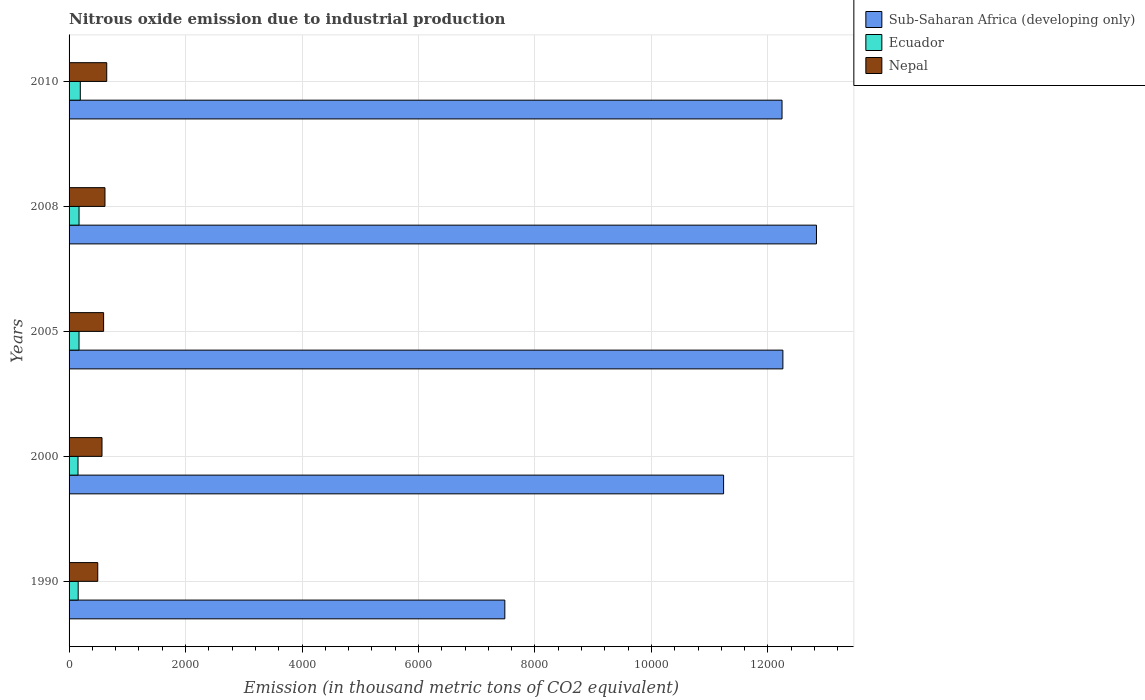How many different coloured bars are there?
Your response must be concise. 3. How many groups of bars are there?
Provide a short and direct response. 5. Are the number of bars on each tick of the Y-axis equal?
Give a very brief answer. Yes. How many bars are there on the 4th tick from the bottom?
Make the answer very short. 3. What is the label of the 2nd group of bars from the top?
Give a very brief answer. 2008. In how many cases, is the number of bars for a given year not equal to the number of legend labels?
Your response must be concise. 0. What is the amount of nitrous oxide emitted in Ecuador in 2008?
Your response must be concise. 171.4. Across all years, what is the maximum amount of nitrous oxide emitted in Nepal?
Your response must be concise. 646.7. Across all years, what is the minimum amount of nitrous oxide emitted in Nepal?
Your response must be concise. 492.4. In which year was the amount of nitrous oxide emitted in Sub-Saharan Africa (developing only) maximum?
Keep it short and to the point. 2008. In which year was the amount of nitrous oxide emitted in Ecuador minimum?
Give a very brief answer. 2000. What is the total amount of nitrous oxide emitted in Nepal in the graph?
Provide a short and direct response. 2913.8. What is the difference between the amount of nitrous oxide emitted in Sub-Saharan Africa (developing only) in 2005 and that in 2010?
Your response must be concise. 14.6. What is the difference between the amount of nitrous oxide emitted in Nepal in 2010 and the amount of nitrous oxide emitted in Ecuador in 2000?
Keep it short and to the point. 493. What is the average amount of nitrous oxide emitted in Ecuador per year?
Your answer should be compact. 169.1. In the year 1990, what is the difference between the amount of nitrous oxide emitted in Ecuador and amount of nitrous oxide emitted in Sub-Saharan Africa (developing only)?
Your answer should be compact. -7325.8. What is the ratio of the amount of nitrous oxide emitted in Ecuador in 2000 to that in 2010?
Provide a succinct answer. 0.8. Is the difference between the amount of nitrous oxide emitted in Ecuador in 2005 and 2008 greater than the difference between the amount of nitrous oxide emitted in Sub-Saharan Africa (developing only) in 2005 and 2008?
Provide a short and direct response. Yes. What is the difference between the highest and the second highest amount of nitrous oxide emitted in Sub-Saharan Africa (developing only)?
Your answer should be compact. 576.6. What is the difference between the highest and the lowest amount of nitrous oxide emitted in Sub-Saharan Africa (developing only)?
Keep it short and to the point. 5351.1. In how many years, is the amount of nitrous oxide emitted in Nepal greater than the average amount of nitrous oxide emitted in Nepal taken over all years?
Keep it short and to the point. 3. Is the sum of the amount of nitrous oxide emitted in Nepal in 1990 and 2008 greater than the maximum amount of nitrous oxide emitted in Sub-Saharan Africa (developing only) across all years?
Offer a terse response. No. What does the 3rd bar from the top in 2000 represents?
Make the answer very short. Sub-Saharan Africa (developing only). What does the 2nd bar from the bottom in 2008 represents?
Your answer should be very brief. Ecuador. Is it the case that in every year, the sum of the amount of nitrous oxide emitted in Nepal and amount of nitrous oxide emitted in Ecuador is greater than the amount of nitrous oxide emitted in Sub-Saharan Africa (developing only)?
Ensure brevity in your answer.  No. How many bars are there?
Make the answer very short. 15. Does the graph contain grids?
Ensure brevity in your answer.  Yes. Where does the legend appear in the graph?
Offer a terse response. Top right. How many legend labels are there?
Provide a short and direct response. 3. What is the title of the graph?
Give a very brief answer. Nitrous oxide emission due to industrial production. What is the label or title of the X-axis?
Offer a very short reply. Emission (in thousand metric tons of CO2 equivalent). What is the Emission (in thousand metric tons of CO2 equivalent) in Sub-Saharan Africa (developing only) in 1990?
Your response must be concise. 7482.3. What is the Emission (in thousand metric tons of CO2 equivalent) of Ecuador in 1990?
Keep it short and to the point. 156.5. What is the Emission (in thousand metric tons of CO2 equivalent) of Nepal in 1990?
Your response must be concise. 492.4. What is the Emission (in thousand metric tons of CO2 equivalent) in Sub-Saharan Africa (developing only) in 2000?
Keep it short and to the point. 1.12e+04. What is the Emission (in thousand metric tons of CO2 equivalent) of Ecuador in 2000?
Your answer should be compact. 153.7. What is the Emission (in thousand metric tons of CO2 equivalent) of Nepal in 2000?
Offer a terse response. 565.3. What is the Emission (in thousand metric tons of CO2 equivalent) in Sub-Saharan Africa (developing only) in 2005?
Keep it short and to the point. 1.23e+04. What is the Emission (in thousand metric tons of CO2 equivalent) in Ecuador in 2005?
Ensure brevity in your answer.  171.1. What is the Emission (in thousand metric tons of CO2 equivalent) of Nepal in 2005?
Your answer should be very brief. 593.1. What is the Emission (in thousand metric tons of CO2 equivalent) of Sub-Saharan Africa (developing only) in 2008?
Provide a short and direct response. 1.28e+04. What is the Emission (in thousand metric tons of CO2 equivalent) of Ecuador in 2008?
Your response must be concise. 171.4. What is the Emission (in thousand metric tons of CO2 equivalent) of Nepal in 2008?
Your answer should be very brief. 616.3. What is the Emission (in thousand metric tons of CO2 equivalent) of Sub-Saharan Africa (developing only) in 2010?
Your response must be concise. 1.22e+04. What is the Emission (in thousand metric tons of CO2 equivalent) in Ecuador in 2010?
Keep it short and to the point. 192.8. What is the Emission (in thousand metric tons of CO2 equivalent) of Nepal in 2010?
Your response must be concise. 646.7. Across all years, what is the maximum Emission (in thousand metric tons of CO2 equivalent) of Sub-Saharan Africa (developing only)?
Give a very brief answer. 1.28e+04. Across all years, what is the maximum Emission (in thousand metric tons of CO2 equivalent) of Ecuador?
Offer a very short reply. 192.8. Across all years, what is the maximum Emission (in thousand metric tons of CO2 equivalent) in Nepal?
Your answer should be compact. 646.7. Across all years, what is the minimum Emission (in thousand metric tons of CO2 equivalent) in Sub-Saharan Africa (developing only)?
Give a very brief answer. 7482.3. Across all years, what is the minimum Emission (in thousand metric tons of CO2 equivalent) of Ecuador?
Your answer should be compact. 153.7. Across all years, what is the minimum Emission (in thousand metric tons of CO2 equivalent) of Nepal?
Ensure brevity in your answer.  492.4. What is the total Emission (in thousand metric tons of CO2 equivalent) of Sub-Saharan Africa (developing only) in the graph?
Make the answer very short. 5.61e+04. What is the total Emission (in thousand metric tons of CO2 equivalent) of Ecuador in the graph?
Provide a succinct answer. 845.5. What is the total Emission (in thousand metric tons of CO2 equivalent) in Nepal in the graph?
Keep it short and to the point. 2913.8. What is the difference between the Emission (in thousand metric tons of CO2 equivalent) of Sub-Saharan Africa (developing only) in 1990 and that in 2000?
Provide a short and direct response. -3756.4. What is the difference between the Emission (in thousand metric tons of CO2 equivalent) in Nepal in 1990 and that in 2000?
Your answer should be compact. -72.9. What is the difference between the Emission (in thousand metric tons of CO2 equivalent) in Sub-Saharan Africa (developing only) in 1990 and that in 2005?
Your answer should be very brief. -4774.5. What is the difference between the Emission (in thousand metric tons of CO2 equivalent) in Ecuador in 1990 and that in 2005?
Keep it short and to the point. -14.6. What is the difference between the Emission (in thousand metric tons of CO2 equivalent) in Nepal in 1990 and that in 2005?
Provide a succinct answer. -100.7. What is the difference between the Emission (in thousand metric tons of CO2 equivalent) of Sub-Saharan Africa (developing only) in 1990 and that in 2008?
Offer a terse response. -5351.1. What is the difference between the Emission (in thousand metric tons of CO2 equivalent) in Ecuador in 1990 and that in 2008?
Offer a terse response. -14.9. What is the difference between the Emission (in thousand metric tons of CO2 equivalent) of Nepal in 1990 and that in 2008?
Your response must be concise. -123.9. What is the difference between the Emission (in thousand metric tons of CO2 equivalent) of Sub-Saharan Africa (developing only) in 1990 and that in 2010?
Provide a succinct answer. -4759.9. What is the difference between the Emission (in thousand metric tons of CO2 equivalent) in Ecuador in 1990 and that in 2010?
Your answer should be compact. -36.3. What is the difference between the Emission (in thousand metric tons of CO2 equivalent) of Nepal in 1990 and that in 2010?
Keep it short and to the point. -154.3. What is the difference between the Emission (in thousand metric tons of CO2 equivalent) of Sub-Saharan Africa (developing only) in 2000 and that in 2005?
Your response must be concise. -1018.1. What is the difference between the Emission (in thousand metric tons of CO2 equivalent) of Ecuador in 2000 and that in 2005?
Provide a succinct answer. -17.4. What is the difference between the Emission (in thousand metric tons of CO2 equivalent) of Nepal in 2000 and that in 2005?
Give a very brief answer. -27.8. What is the difference between the Emission (in thousand metric tons of CO2 equivalent) of Sub-Saharan Africa (developing only) in 2000 and that in 2008?
Provide a short and direct response. -1594.7. What is the difference between the Emission (in thousand metric tons of CO2 equivalent) in Ecuador in 2000 and that in 2008?
Make the answer very short. -17.7. What is the difference between the Emission (in thousand metric tons of CO2 equivalent) of Nepal in 2000 and that in 2008?
Your answer should be compact. -51. What is the difference between the Emission (in thousand metric tons of CO2 equivalent) in Sub-Saharan Africa (developing only) in 2000 and that in 2010?
Provide a succinct answer. -1003.5. What is the difference between the Emission (in thousand metric tons of CO2 equivalent) in Ecuador in 2000 and that in 2010?
Your answer should be compact. -39.1. What is the difference between the Emission (in thousand metric tons of CO2 equivalent) in Nepal in 2000 and that in 2010?
Offer a terse response. -81.4. What is the difference between the Emission (in thousand metric tons of CO2 equivalent) in Sub-Saharan Africa (developing only) in 2005 and that in 2008?
Offer a terse response. -576.6. What is the difference between the Emission (in thousand metric tons of CO2 equivalent) of Ecuador in 2005 and that in 2008?
Offer a terse response. -0.3. What is the difference between the Emission (in thousand metric tons of CO2 equivalent) of Nepal in 2005 and that in 2008?
Your response must be concise. -23.2. What is the difference between the Emission (in thousand metric tons of CO2 equivalent) in Ecuador in 2005 and that in 2010?
Provide a short and direct response. -21.7. What is the difference between the Emission (in thousand metric tons of CO2 equivalent) in Nepal in 2005 and that in 2010?
Provide a short and direct response. -53.6. What is the difference between the Emission (in thousand metric tons of CO2 equivalent) of Sub-Saharan Africa (developing only) in 2008 and that in 2010?
Make the answer very short. 591.2. What is the difference between the Emission (in thousand metric tons of CO2 equivalent) in Ecuador in 2008 and that in 2010?
Your answer should be very brief. -21.4. What is the difference between the Emission (in thousand metric tons of CO2 equivalent) in Nepal in 2008 and that in 2010?
Your answer should be compact. -30.4. What is the difference between the Emission (in thousand metric tons of CO2 equivalent) of Sub-Saharan Africa (developing only) in 1990 and the Emission (in thousand metric tons of CO2 equivalent) of Ecuador in 2000?
Offer a terse response. 7328.6. What is the difference between the Emission (in thousand metric tons of CO2 equivalent) of Sub-Saharan Africa (developing only) in 1990 and the Emission (in thousand metric tons of CO2 equivalent) of Nepal in 2000?
Your answer should be compact. 6917. What is the difference between the Emission (in thousand metric tons of CO2 equivalent) of Ecuador in 1990 and the Emission (in thousand metric tons of CO2 equivalent) of Nepal in 2000?
Make the answer very short. -408.8. What is the difference between the Emission (in thousand metric tons of CO2 equivalent) in Sub-Saharan Africa (developing only) in 1990 and the Emission (in thousand metric tons of CO2 equivalent) in Ecuador in 2005?
Your answer should be very brief. 7311.2. What is the difference between the Emission (in thousand metric tons of CO2 equivalent) of Sub-Saharan Africa (developing only) in 1990 and the Emission (in thousand metric tons of CO2 equivalent) of Nepal in 2005?
Provide a succinct answer. 6889.2. What is the difference between the Emission (in thousand metric tons of CO2 equivalent) of Ecuador in 1990 and the Emission (in thousand metric tons of CO2 equivalent) of Nepal in 2005?
Offer a very short reply. -436.6. What is the difference between the Emission (in thousand metric tons of CO2 equivalent) of Sub-Saharan Africa (developing only) in 1990 and the Emission (in thousand metric tons of CO2 equivalent) of Ecuador in 2008?
Offer a terse response. 7310.9. What is the difference between the Emission (in thousand metric tons of CO2 equivalent) in Sub-Saharan Africa (developing only) in 1990 and the Emission (in thousand metric tons of CO2 equivalent) in Nepal in 2008?
Offer a terse response. 6866. What is the difference between the Emission (in thousand metric tons of CO2 equivalent) of Ecuador in 1990 and the Emission (in thousand metric tons of CO2 equivalent) of Nepal in 2008?
Offer a very short reply. -459.8. What is the difference between the Emission (in thousand metric tons of CO2 equivalent) of Sub-Saharan Africa (developing only) in 1990 and the Emission (in thousand metric tons of CO2 equivalent) of Ecuador in 2010?
Provide a short and direct response. 7289.5. What is the difference between the Emission (in thousand metric tons of CO2 equivalent) in Sub-Saharan Africa (developing only) in 1990 and the Emission (in thousand metric tons of CO2 equivalent) in Nepal in 2010?
Ensure brevity in your answer.  6835.6. What is the difference between the Emission (in thousand metric tons of CO2 equivalent) in Ecuador in 1990 and the Emission (in thousand metric tons of CO2 equivalent) in Nepal in 2010?
Offer a very short reply. -490.2. What is the difference between the Emission (in thousand metric tons of CO2 equivalent) of Sub-Saharan Africa (developing only) in 2000 and the Emission (in thousand metric tons of CO2 equivalent) of Ecuador in 2005?
Make the answer very short. 1.11e+04. What is the difference between the Emission (in thousand metric tons of CO2 equivalent) of Sub-Saharan Africa (developing only) in 2000 and the Emission (in thousand metric tons of CO2 equivalent) of Nepal in 2005?
Your response must be concise. 1.06e+04. What is the difference between the Emission (in thousand metric tons of CO2 equivalent) of Ecuador in 2000 and the Emission (in thousand metric tons of CO2 equivalent) of Nepal in 2005?
Make the answer very short. -439.4. What is the difference between the Emission (in thousand metric tons of CO2 equivalent) in Sub-Saharan Africa (developing only) in 2000 and the Emission (in thousand metric tons of CO2 equivalent) in Ecuador in 2008?
Offer a very short reply. 1.11e+04. What is the difference between the Emission (in thousand metric tons of CO2 equivalent) of Sub-Saharan Africa (developing only) in 2000 and the Emission (in thousand metric tons of CO2 equivalent) of Nepal in 2008?
Offer a very short reply. 1.06e+04. What is the difference between the Emission (in thousand metric tons of CO2 equivalent) in Ecuador in 2000 and the Emission (in thousand metric tons of CO2 equivalent) in Nepal in 2008?
Give a very brief answer. -462.6. What is the difference between the Emission (in thousand metric tons of CO2 equivalent) in Sub-Saharan Africa (developing only) in 2000 and the Emission (in thousand metric tons of CO2 equivalent) in Ecuador in 2010?
Your answer should be very brief. 1.10e+04. What is the difference between the Emission (in thousand metric tons of CO2 equivalent) of Sub-Saharan Africa (developing only) in 2000 and the Emission (in thousand metric tons of CO2 equivalent) of Nepal in 2010?
Make the answer very short. 1.06e+04. What is the difference between the Emission (in thousand metric tons of CO2 equivalent) in Ecuador in 2000 and the Emission (in thousand metric tons of CO2 equivalent) in Nepal in 2010?
Give a very brief answer. -493. What is the difference between the Emission (in thousand metric tons of CO2 equivalent) of Sub-Saharan Africa (developing only) in 2005 and the Emission (in thousand metric tons of CO2 equivalent) of Ecuador in 2008?
Your answer should be compact. 1.21e+04. What is the difference between the Emission (in thousand metric tons of CO2 equivalent) of Sub-Saharan Africa (developing only) in 2005 and the Emission (in thousand metric tons of CO2 equivalent) of Nepal in 2008?
Offer a very short reply. 1.16e+04. What is the difference between the Emission (in thousand metric tons of CO2 equivalent) of Ecuador in 2005 and the Emission (in thousand metric tons of CO2 equivalent) of Nepal in 2008?
Keep it short and to the point. -445.2. What is the difference between the Emission (in thousand metric tons of CO2 equivalent) in Sub-Saharan Africa (developing only) in 2005 and the Emission (in thousand metric tons of CO2 equivalent) in Ecuador in 2010?
Provide a short and direct response. 1.21e+04. What is the difference between the Emission (in thousand metric tons of CO2 equivalent) of Sub-Saharan Africa (developing only) in 2005 and the Emission (in thousand metric tons of CO2 equivalent) of Nepal in 2010?
Provide a short and direct response. 1.16e+04. What is the difference between the Emission (in thousand metric tons of CO2 equivalent) in Ecuador in 2005 and the Emission (in thousand metric tons of CO2 equivalent) in Nepal in 2010?
Your answer should be very brief. -475.6. What is the difference between the Emission (in thousand metric tons of CO2 equivalent) of Sub-Saharan Africa (developing only) in 2008 and the Emission (in thousand metric tons of CO2 equivalent) of Ecuador in 2010?
Offer a very short reply. 1.26e+04. What is the difference between the Emission (in thousand metric tons of CO2 equivalent) of Sub-Saharan Africa (developing only) in 2008 and the Emission (in thousand metric tons of CO2 equivalent) of Nepal in 2010?
Offer a very short reply. 1.22e+04. What is the difference between the Emission (in thousand metric tons of CO2 equivalent) in Ecuador in 2008 and the Emission (in thousand metric tons of CO2 equivalent) in Nepal in 2010?
Provide a short and direct response. -475.3. What is the average Emission (in thousand metric tons of CO2 equivalent) in Sub-Saharan Africa (developing only) per year?
Give a very brief answer. 1.12e+04. What is the average Emission (in thousand metric tons of CO2 equivalent) in Ecuador per year?
Offer a terse response. 169.1. What is the average Emission (in thousand metric tons of CO2 equivalent) of Nepal per year?
Your answer should be very brief. 582.76. In the year 1990, what is the difference between the Emission (in thousand metric tons of CO2 equivalent) in Sub-Saharan Africa (developing only) and Emission (in thousand metric tons of CO2 equivalent) in Ecuador?
Ensure brevity in your answer.  7325.8. In the year 1990, what is the difference between the Emission (in thousand metric tons of CO2 equivalent) of Sub-Saharan Africa (developing only) and Emission (in thousand metric tons of CO2 equivalent) of Nepal?
Provide a short and direct response. 6989.9. In the year 1990, what is the difference between the Emission (in thousand metric tons of CO2 equivalent) of Ecuador and Emission (in thousand metric tons of CO2 equivalent) of Nepal?
Your answer should be compact. -335.9. In the year 2000, what is the difference between the Emission (in thousand metric tons of CO2 equivalent) in Sub-Saharan Africa (developing only) and Emission (in thousand metric tons of CO2 equivalent) in Ecuador?
Offer a very short reply. 1.11e+04. In the year 2000, what is the difference between the Emission (in thousand metric tons of CO2 equivalent) in Sub-Saharan Africa (developing only) and Emission (in thousand metric tons of CO2 equivalent) in Nepal?
Your answer should be very brief. 1.07e+04. In the year 2000, what is the difference between the Emission (in thousand metric tons of CO2 equivalent) in Ecuador and Emission (in thousand metric tons of CO2 equivalent) in Nepal?
Ensure brevity in your answer.  -411.6. In the year 2005, what is the difference between the Emission (in thousand metric tons of CO2 equivalent) of Sub-Saharan Africa (developing only) and Emission (in thousand metric tons of CO2 equivalent) of Ecuador?
Your response must be concise. 1.21e+04. In the year 2005, what is the difference between the Emission (in thousand metric tons of CO2 equivalent) in Sub-Saharan Africa (developing only) and Emission (in thousand metric tons of CO2 equivalent) in Nepal?
Your answer should be compact. 1.17e+04. In the year 2005, what is the difference between the Emission (in thousand metric tons of CO2 equivalent) of Ecuador and Emission (in thousand metric tons of CO2 equivalent) of Nepal?
Provide a short and direct response. -422. In the year 2008, what is the difference between the Emission (in thousand metric tons of CO2 equivalent) of Sub-Saharan Africa (developing only) and Emission (in thousand metric tons of CO2 equivalent) of Ecuador?
Your response must be concise. 1.27e+04. In the year 2008, what is the difference between the Emission (in thousand metric tons of CO2 equivalent) of Sub-Saharan Africa (developing only) and Emission (in thousand metric tons of CO2 equivalent) of Nepal?
Give a very brief answer. 1.22e+04. In the year 2008, what is the difference between the Emission (in thousand metric tons of CO2 equivalent) of Ecuador and Emission (in thousand metric tons of CO2 equivalent) of Nepal?
Your answer should be very brief. -444.9. In the year 2010, what is the difference between the Emission (in thousand metric tons of CO2 equivalent) in Sub-Saharan Africa (developing only) and Emission (in thousand metric tons of CO2 equivalent) in Ecuador?
Offer a terse response. 1.20e+04. In the year 2010, what is the difference between the Emission (in thousand metric tons of CO2 equivalent) in Sub-Saharan Africa (developing only) and Emission (in thousand metric tons of CO2 equivalent) in Nepal?
Your answer should be very brief. 1.16e+04. In the year 2010, what is the difference between the Emission (in thousand metric tons of CO2 equivalent) of Ecuador and Emission (in thousand metric tons of CO2 equivalent) of Nepal?
Provide a short and direct response. -453.9. What is the ratio of the Emission (in thousand metric tons of CO2 equivalent) in Sub-Saharan Africa (developing only) in 1990 to that in 2000?
Your answer should be compact. 0.67. What is the ratio of the Emission (in thousand metric tons of CO2 equivalent) in Ecuador in 1990 to that in 2000?
Your response must be concise. 1.02. What is the ratio of the Emission (in thousand metric tons of CO2 equivalent) of Nepal in 1990 to that in 2000?
Keep it short and to the point. 0.87. What is the ratio of the Emission (in thousand metric tons of CO2 equivalent) of Sub-Saharan Africa (developing only) in 1990 to that in 2005?
Keep it short and to the point. 0.61. What is the ratio of the Emission (in thousand metric tons of CO2 equivalent) in Ecuador in 1990 to that in 2005?
Offer a very short reply. 0.91. What is the ratio of the Emission (in thousand metric tons of CO2 equivalent) of Nepal in 1990 to that in 2005?
Offer a very short reply. 0.83. What is the ratio of the Emission (in thousand metric tons of CO2 equivalent) in Sub-Saharan Africa (developing only) in 1990 to that in 2008?
Provide a succinct answer. 0.58. What is the ratio of the Emission (in thousand metric tons of CO2 equivalent) in Ecuador in 1990 to that in 2008?
Provide a short and direct response. 0.91. What is the ratio of the Emission (in thousand metric tons of CO2 equivalent) of Nepal in 1990 to that in 2008?
Make the answer very short. 0.8. What is the ratio of the Emission (in thousand metric tons of CO2 equivalent) in Sub-Saharan Africa (developing only) in 1990 to that in 2010?
Your answer should be compact. 0.61. What is the ratio of the Emission (in thousand metric tons of CO2 equivalent) of Ecuador in 1990 to that in 2010?
Your response must be concise. 0.81. What is the ratio of the Emission (in thousand metric tons of CO2 equivalent) in Nepal in 1990 to that in 2010?
Provide a succinct answer. 0.76. What is the ratio of the Emission (in thousand metric tons of CO2 equivalent) of Sub-Saharan Africa (developing only) in 2000 to that in 2005?
Offer a terse response. 0.92. What is the ratio of the Emission (in thousand metric tons of CO2 equivalent) of Ecuador in 2000 to that in 2005?
Provide a short and direct response. 0.9. What is the ratio of the Emission (in thousand metric tons of CO2 equivalent) in Nepal in 2000 to that in 2005?
Your answer should be compact. 0.95. What is the ratio of the Emission (in thousand metric tons of CO2 equivalent) in Sub-Saharan Africa (developing only) in 2000 to that in 2008?
Keep it short and to the point. 0.88. What is the ratio of the Emission (in thousand metric tons of CO2 equivalent) in Ecuador in 2000 to that in 2008?
Offer a terse response. 0.9. What is the ratio of the Emission (in thousand metric tons of CO2 equivalent) of Nepal in 2000 to that in 2008?
Give a very brief answer. 0.92. What is the ratio of the Emission (in thousand metric tons of CO2 equivalent) of Sub-Saharan Africa (developing only) in 2000 to that in 2010?
Your answer should be very brief. 0.92. What is the ratio of the Emission (in thousand metric tons of CO2 equivalent) in Ecuador in 2000 to that in 2010?
Your answer should be very brief. 0.8. What is the ratio of the Emission (in thousand metric tons of CO2 equivalent) of Nepal in 2000 to that in 2010?
Your answer should be very brief. 0.87. What is the ratio of the Emission (in thousand metric tons of CO2 equivalent) of Sub-Saharan Africa (developing only) in 2005 to that in 2008?
Provide a succinct answer. 0.96. What is the ratio of the Emission (in thousand metric tons of CO2 equivalent) in Nepal in 2005 to that in 2008?
Offer a terse response. 0.96. What is the ratio of the Emission (in thousand metric tons of CO2 equivalent) of Ecuador in 2005 to that in 2010?
Provide a short and direct response. 0.89. What is the ratio of the Emission (in thousand metric tons of CO2 equivalent) in Nepal in 2005 to that in 2010?
Provide a short and direct response. 0.92. What is the ratio of the Emission (in thousand metric tons of CO2 equivalent) of Sub-Saharan Africa (developing only) in 2008 to that in 2010?
Your answer should be very brief. 1.05. What is the ratio of the Emission (in thousand metric tons of CO2 equivalent) of Ecuador in 2008 to that in 2010?
Offer a terse response. 0.89. What is the ratio of the Emission (in thousand metric tons of CO2 equivalent) of Nepal in 2008 to that in 2010?
Ensure brevity in your answer.  0.95. What is the difference between the highest and the second highest Emission (in thousand metric tons of CO2 equivalent) in Sub-Saharan Africa (developing only)?
Make the answer very short. 576.6. What is the difference between the highest and the second highest Emission (in thousand metric tons of CO2 equivalent) of Ecuador?
Make the answer very short. 21.4. What is the difference between the highest and the second highest Emission (in thousand metric tons of CO2 equivalent) in Nepal?
Provide a short and direct response. 30.4. What is the difference between the highest and the lowest Emission (in thousand metric tons of CO2 equivalent) of Sub-Saharan Africa (developing only)?
Provide a succinct answer. 5351.1. What is the difference between the highest and the lowest Emission (in thousand metric tons of CO2 equivalent) in Ecuador?
Your answer should be compact. 39.1. What is the difference between the highest and the lowest Emission (in thousand metric tons of CO2 equivalent) in Nepal?
Provide a succinct answer. 154.3. 